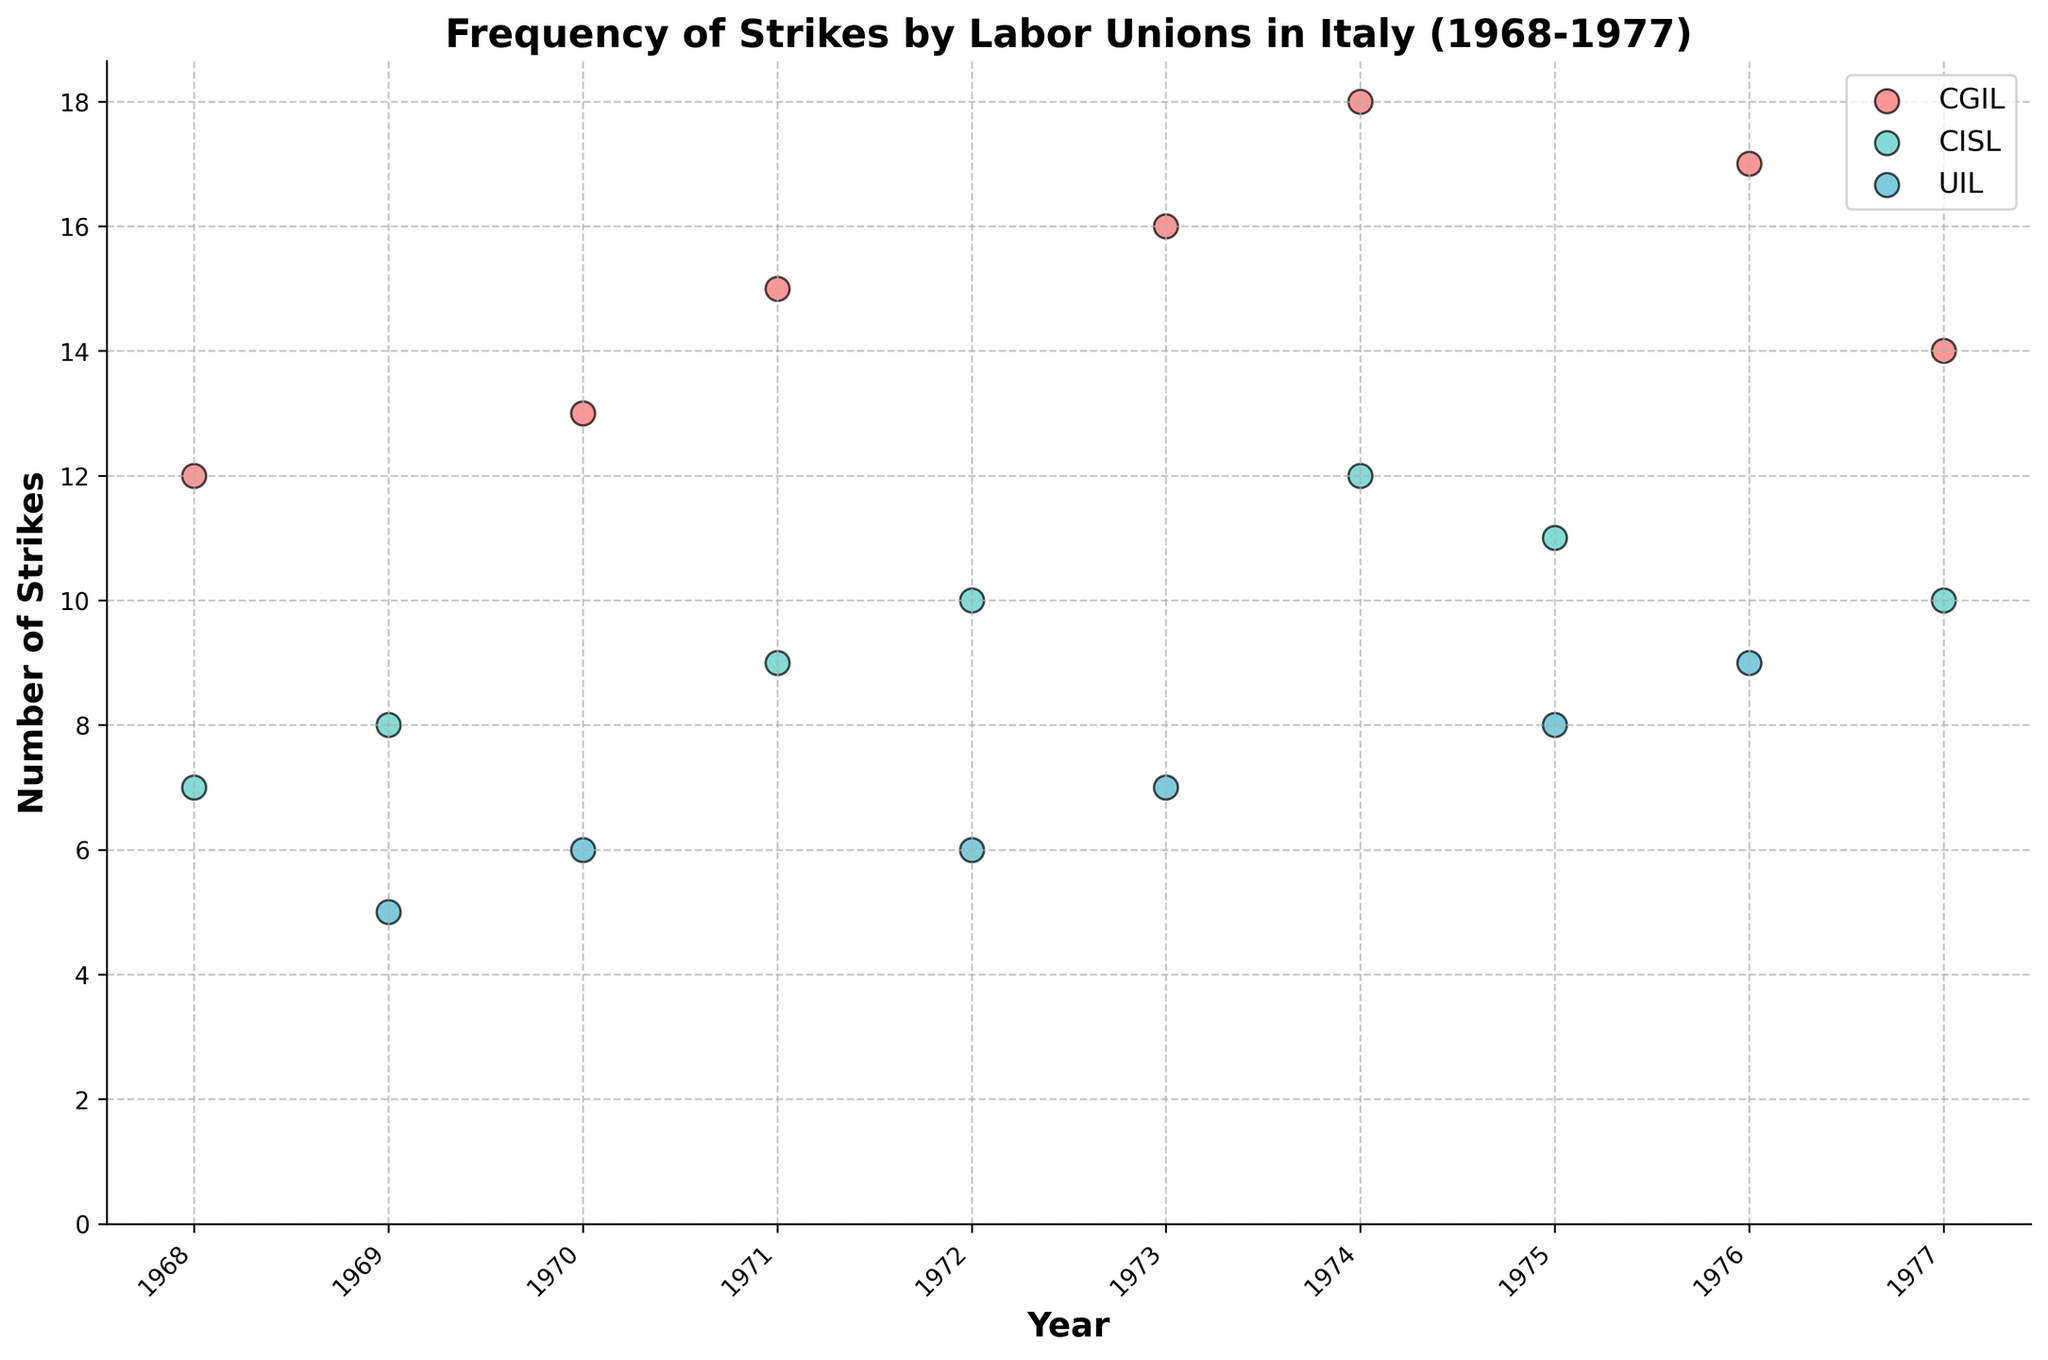What is the title of the plot? The title of the plot is located at the top center of the figure in bold font.
Answer: Frequency of Strikes by Labor Unions in Italy (1968-1977) Which union had the highest number of strikes in 1974? To find the union with the highest number of strikes in 1974, locate the x-axis labeled "Year," and find the point corresponding to 1974, then check the y-value and the color of the point to identify the union.
Answer: CGIL How many strikes did CGIL have in 1971? Locate the year 1971 on the x-axis. Find the point colored corresponding to CGIL and check its y-value to determine the number of strikes.
Answer: 15 What is the average number of strikes for CISL between 1968 and 1977? First, extract the number of strikes for CISL for each year (7, 8, 10, 9, 10, 12, 11, 10) and calculate the sum (77). Then, divide by the number of years (8).
Answer: 9.625 Which years did UIL have fewer strikes than CGIL? Compare the data points for UIL and CGIL across all years (1968-1977). Specifically, look at the y-values of the points respective to the colors of UIL and CGIL.
Answer: 1968, 1969, 1970, 1971, 1972, 1973, 1975, 1977 In which year did CGIL experience the greatest increase in strikes compared to the previous year? Track the difference in the number of strikes of CGIL year over year and identify the year with the highest positive change.
Answer: 1976 How many total strikes were carried out by all unions in 1973? Sum the number of strikes by CGIL, CISL, and UIL in 1973.
Answer: 35 Which union had the lowest average number of strikes over the period of 1968 to 1977? Calculate the average number of strikes for each union individually over the given period and then identify the smallest average.
Answer: UIL What is the most frequent number of strikes for CGIL? Observe the scatter points corresponding to CGIL and determine the most recurrent y-value among them.
Answer: 14 Did CISL or UIL have more variability in the number of strikes from 1968 to 1977? To assess variability, compare the range or standard deviation of the number of strikes for CISL and UIL.
Answer: CISL 